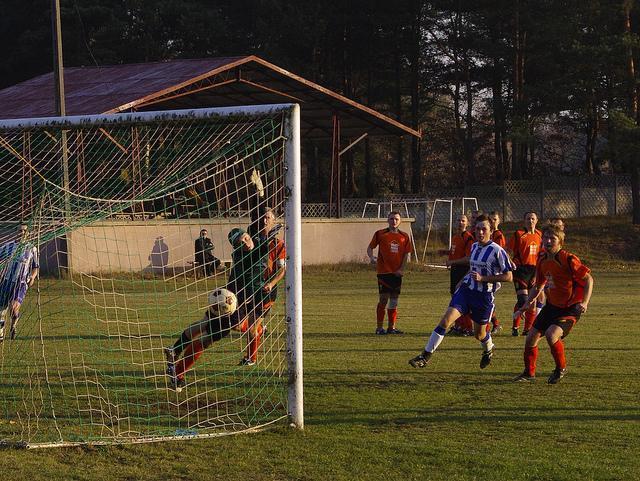How many goals are there?
Give a very brief answer. 2. How many people are in the picture?
Give a very brief answer. 6. How many elephants are there?
Give a very brief answer. 0. 